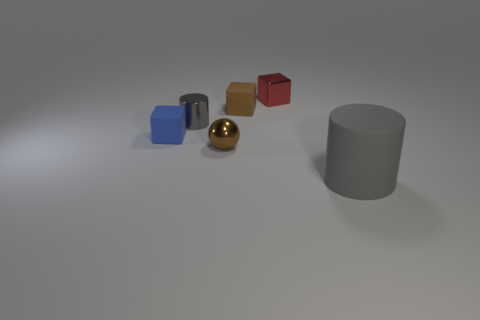Are there any other tiny matte objects that have the same shape as the blue matte thing?
Your answer should be very brief. Yes. What shape is the shiny object that is both right of the gray metal cylinder and to the left of the brown rubber cube?
Your answer should be compact. Sphere. Do the tiny cylinder and the cube that is on the left side of the metallic cylinder have the same material?
Ensure brevity in your answer.  No. There is a small gray thing; are there any gray objects in front of it?
Offer a very short reply. Yes. How many objects are either big cylinders or tiny brown objects in front of the small gray metallic object?
Ensure brevity in your answer.  2. The small metallic object left of the small thing that is in front of the blue thing is what color?
Provide a succinct answer. Gray. What number of other objects are there of the same material as the small ball?
Your answer should be compact. 2. What number of matte things are either small objects or large yellow cylinders?
Your answer should be compact. 2. What color is the small metal thing that is the same shape as the brown matte thing?
Your answer should be very brief. Red. What number of objects are either brown cubes or blue metallic spheres?
Provide a short and direct response. 1. 